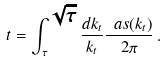<formula> <loc_0><loc_0><loc_500><loc_500>t = \int _ { \tau } ^ { \sqrt { \tau } } \frac { d k _ { t } } { k _ { t } } \frac { \ a s ( k _ { t } ) } { 2 \pi } \, .</formula> 